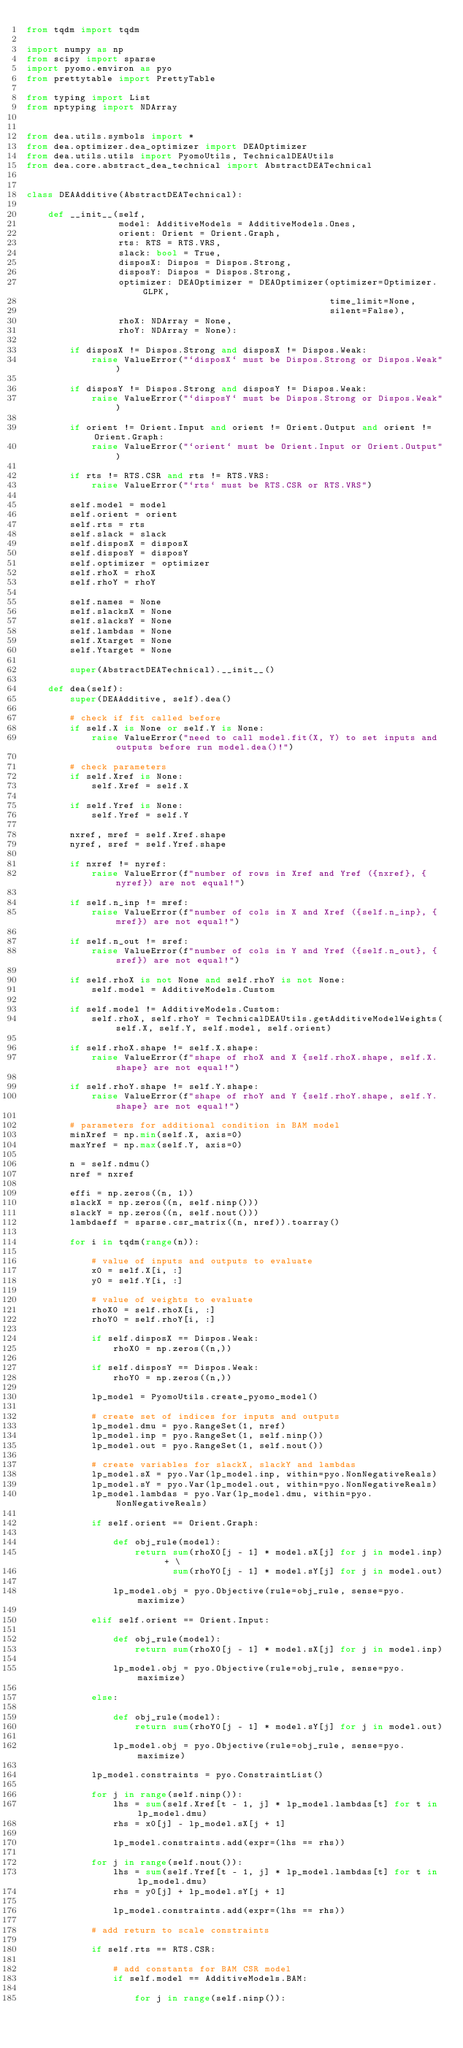Convert code to text. <code><loc_0><loc_0><loc_500><loc_500><_Python_>from tqdm import tqdm

import numpy as np
from scipy import sparse
import pyomo.environ as pyo
from prettytable import PrettyTable

from typing import List
from nptyping import NDArray


from dea.utils.symbols import *
from dea.optimizer.dea_optimizer import DEAOptimizer
from dea.utils.utils import PyomoUtils, TechnicalDEAUtils
from dea.core.abstract_dea_technical import AbstractDEATechnical


class DEAAdditive(AbstractDEATechnical):

    def __init__(self,
                 model: AdditiveModels = AdditiveModels.Ones,
                 orient: Orient = Orient.Graph,
                 rts: RTS = RTS.VRS,
                 slack: bool = True,
                 disposX: Dispos = Dispos.Strong,
                 disposY: Dispos = Dispos.Strong,
                 optimizer: DEAOptimizer = DEAOptimizer(optimizer=Optimizer.GLPK,
                                                        time_limit=None,
                                                        silent=False),
                 rhoX: NDArray = None,
                 rhoY: NDArray = None):

        if disposX != Dispos.Strong and disposX != Dispos.Weak:
            raise ValueError("`disposX` must be Dispos.Strong or Dispos.Weak")

        if disposY != Dispos.Strong and disposY != Dispos.Weak:
            raise ValueError("`disposY` must be Dispos.Strong or Dispos.Weak")

        if orient != Orient.Input and orient != Orient.Output and orient != Orient.Graph:
            raise ValueError("`orient` must be Orient.Input or Orient.Output")

        if rts != RTS.CSR and rts != RTS.VRS:
            raise ValueError("`rts` must be RTS.CSR or RTS.VRS")

        self.model = model
        self.orient = orient
        self.rts = rts
        self.slack = slack
        self.disposX = disposX
        self.disposY = disposY
        self.optimizer = optimizer
        self.rhoX = rhoX
        self.rhoY = rhoY

        self.names = None
        self.slacksX = None
        self.slacksY = None
        self.lambdas = None
        self.Xtarget = None
        self.Ytarget = None

        super(AbstractDEATechnical).__init__()

    def dea(self):
        super(DEAAdditive, self).dea()

        # check if fit called before
        if self.X is None or self.Y is None:
            raise ValueError("need to call model.fit(X, Y) to set inputs and outputs before run model.dea()!")

        # check parameters
        if self.Xref is None:
            self.Xref = self.X

        if self.Yref is None:
            self.Yref = self.Y

        nxref, mref = self.Xref.shape
        nyref, sref = self.Yref.shape

        if nxref != nyref:
            raise ValueError(f"number of rows in Xref and Yref ({nxref}, {nyref}) are not equal!")

        if self.n_inp != mref:
            raise ValueError(f"number of cols in X and Xref ({self.n_inp}, {mref}) are not equal!")

        if self.n_out != sref:
            raise ValueError(f"number of cols in Y and Yref ({self.n_out}, {sref}) are not equal!")

        if self.rhoX is not None and self.rhoY is not None:
            self.model = AdditiveModels.Custom

        if self.model != AdditiveModels.Custom:
            self.rhoX, self.rhoY = TechnicalDEAUtils.getAdditiveModelWeights(self.X, self.Y, self.model, self.orient)

        if self.rhoX.shape != self.X.shape:
            raise ValueError(f"shape of rhoX and X {self.rhoX.shape, self.X.shape} are not equal!")

        if self.rhoY.shape != self.Y.shape:
            raise ValueError(f"shape of rhoY and Y {self.rhoY.shape, self.Y.shape} are not equal!")

        # parameters for additional condition in BAM model
        minXref = np.min(self.X, axis=0)
        maxYref = np.max(self.Y, axis=0)

        n = self.ndmu()
        nref = nxref

        effi = np.zeros((n, 1))
        slackX = np.zeros((n, self.ninp()))
        slackY = np.zeros((n, self.nout()))
        lambdaeff = sparse.csr_matrix((n, nref)).toarray()

        for i in tqdm(range(n)):

            # value of inputs and outputs to evaluate
            x0 = self.X[i, :]
            y0 = self.Y[i, :]

            # value of weights to evaluate
            rhoX0 = self.rhoX[i, :]
            rhoY0 = self.rhoY[i, :]

            if self.disposX == Dispos.Weak:
                rhoX0 = np.zeros((n,))

            if self.disposY == Dispos.Weak:
                rhoY0 = np.zeros((n,))

            lp_model = PyomoUtils.create_pyomo_model()

            # create set of indices for inputs and outputs
            lp_model.dmu = pyo.RangeSet(1, nref)
            lp_model.inp = pyo.RangeSet(1, self.ninp())
            lp_model.out = pyo.RangeSet(1, self.nout())

            # create variables for slackX, slackY and lambdas
            lp_model.sX = pyo.Var(lp_model.inp, within=pyo.NonNegativeReals)
            lp_model.sY = pyo.Var(lp_model.out, within=pyo.NonNegativeReals)
            lp_model.lambdas = pyo.Var(lp_model.dmu, within=pyo.NonNegativeReals)

            if self.orient == Orient.Graph:

                def obj_rule(model):
                    return sum(rhoX0[j - 1] * model.sX[j] for j in model.inp) + \
                           sum(rhoY0[j - 1] * model.sY[j] for j in model.out)

                lp_model.obj = pyo.Objective(rule=obj_rule, sense=pyo.maximize)

            elif self.orient == Orient.Input:

                def obj_rule(model):
                    return sum(rhoX0[j - 1] * model.sX[j] for j in model.inp)

                lp_model.obj = pyo.Objective(rule=obj_rule, sense=pyo.maximize)

            else:

                def obj_rule(model):
                    return sum(rhoY0[j - 1] * model.sY[j] for j in model.out)

                lp_model.obj = pyo.Objective(rule=obj_rule, sense=pyo.maximize)

            lp_model.constraints = pyo.ConstraintList()

            for j in range(self.ninp()):
                lhs = sum(self.Xref[t - 1, j] * lp_model.lambdas[t] for t in lp_model.dmu)
                rhs = x0[j] - lp_model.sX[j + 1]

                lp_model.constraints.add(expr=(lhs == rhs))

            for j in range(self.nout()):
                lhs = sum(self.Yref[t - 1, j] * lp_model.lambdas[t] for t in lp_model.dmu)
                rhs = y0[j] + lp_model.sY[j + 1]

                lp_model.constraints.add(expr=(lhs == rhs))

            # add return to scale constraints

            if self.rts == RTS.CSR:

                # add constants for BAM CSR model
                if self.model == AdditiveModels.BAM:

                    for j in range(self.ninp()):</code> 